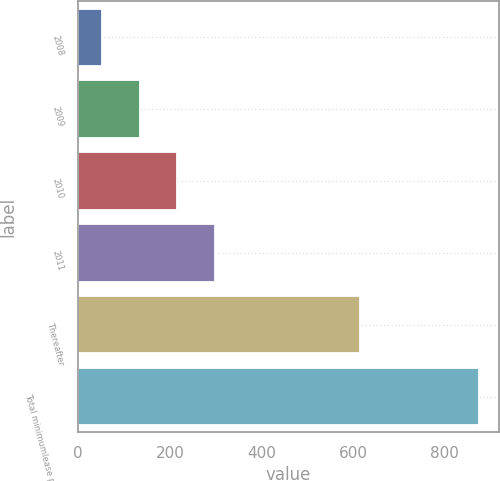Convert chart. <chart><loc_0><loc_0><loc_500><loc_500><bar_chart><fcel>2008<fcel>2009<fcel>2010<fcel>2011<fcel>Thereafter<fcel>Total minimumlease payments<nl><fcel>52<fcel>134.2<fcel>216.4<fcel>298.6<fcel>615<fcel>874<nl></chart> 